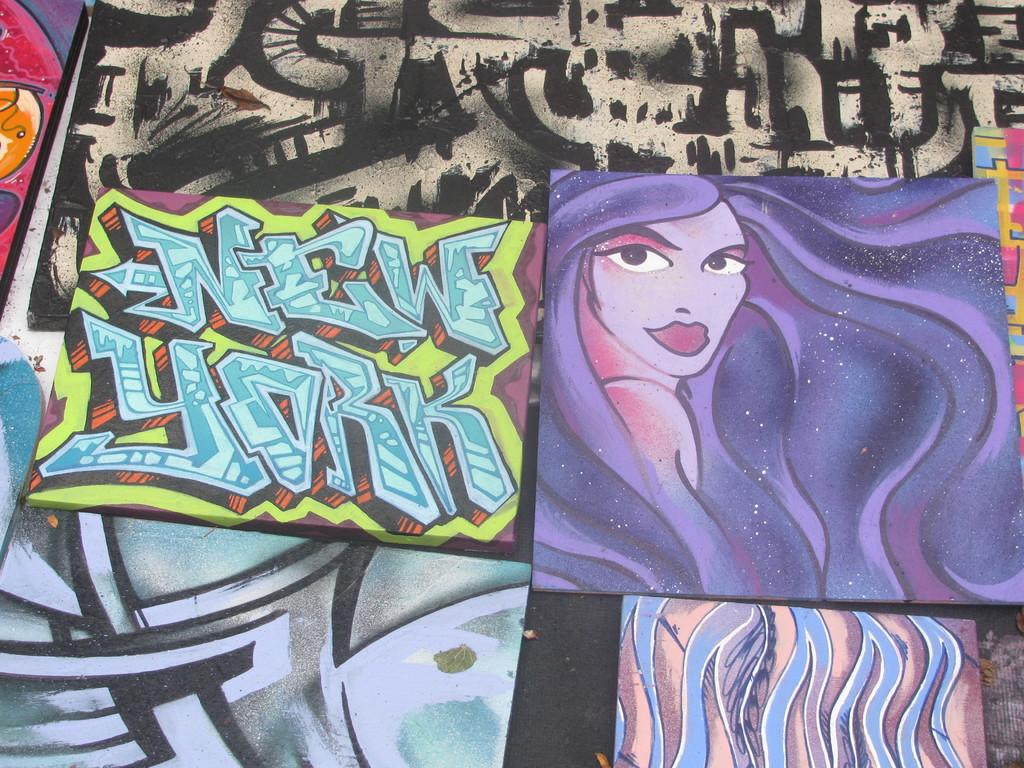What can be seen in the image that is made of different colored boards? There are boards in different colors in the image, and they have painted cartoons and text. What is present in the background of the image? There is a painted wall, known as graffiti, in the background of the image. Can you tell me how many matches are on the boards in the image? There are no matches present on the boards in the image; they have painted cartoons and text instead. 